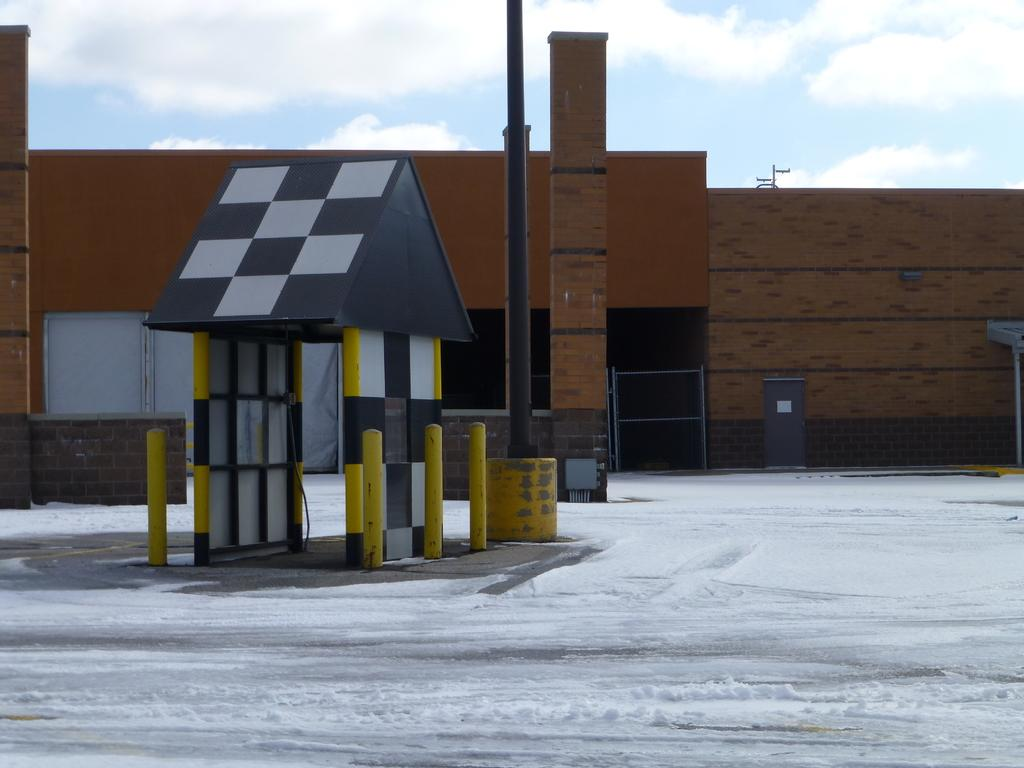What type of structure can be seen in the image? There is a building in the image. Are there any other structures or objects in the image? Yes, there is a shed, pillars, a gate, metal rods, and a pole in the image. What is the color of the black color object in the image? The black color object in the image is not specified, but it is mentioned that there is a black color object present. What is the weather like in the image? The weather in the image is cold, as there is snow visible. What can be seen in the background of the image? The sky with clouds is visible in the background of the image. What type of donkey can be seen in the image? There is no donkey present in the image. How much money is visible in the image? There is no mention of money in the image. What is the name of the building in the image? The name of the building in the image is not mentioned. 